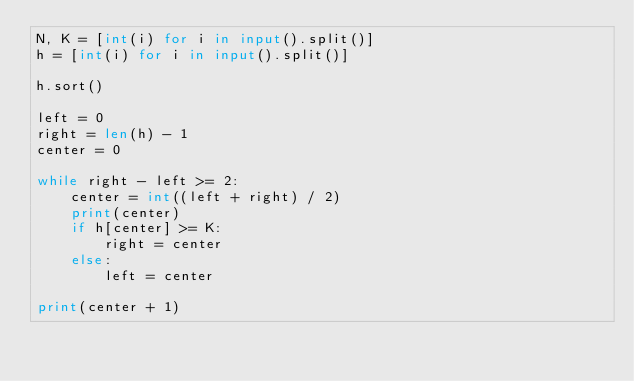<code> <loc_0><loc_0><loc_500><loc_500><_Python_>N, K = [int(i) for i in input().split()]
h = [int(i) for i in input().split()]

h.sort()

left = 0
right = len(h) - 1
center = 0

while right - left >= 2:
    center = int((left + right) / 2)
    print(center)
    if h[center] >= K:
        right = center
    else:
        left = center
    
print(center + 1)</code> 